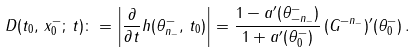Convert formula to latex. <formula><loc_0><loc_0><loc_500><loc_500>D ( t _ { 0 } , \, x _ { 0 } ^ { - } ; \, t ) \colon = \left | \frac { \partial } { \partial t } h ( \theta _ { n _ { - } } ^ { - } , \, t _ { 0 } ) \right | = \frac { 1 - a ^ { \prime } ( \theta ^ { - } _ { - n _ { - } } ) } { 1 + a ^ { \prime } ( \theta ^ { - } _ { 0 } ) } \, ( G ^ { - n _ { - } } ) ^ { \prime } ( \theta _ { 0 } ^ { - } ) \, .</formula> 